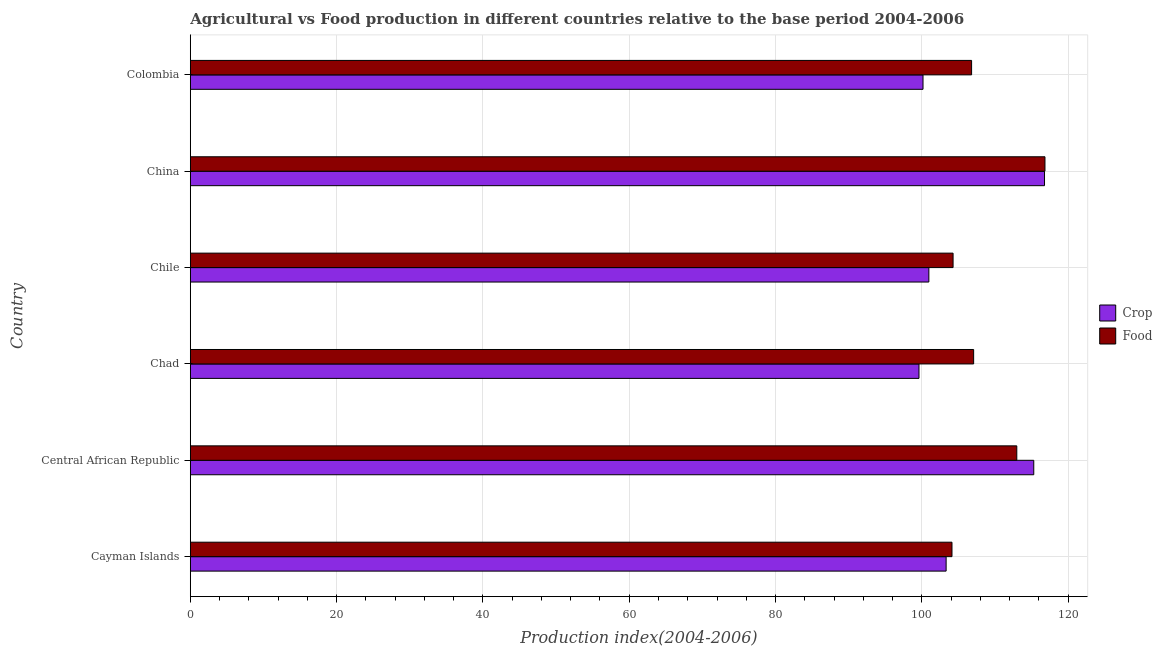How many different coloured bars are there?
Offer a very short reply. 2. How many groups of bars are there?
Keep it short and to the point. 6. Are the number of bars per tick equal to the number of legend labels?
Keep it short and to the point. Yes. Are the number of bars on each tick of the Y-axis equal?
Give a very brief answer. Yes. How many bars are there on the 6th tick from the top?
Your answer should be compact. 2. How many bars are there on the 6th tick from the bottom?
Offer a terse response. 2. What is the label of the 5th group of bars from the top?
Give a very brief answer. Central African Republic. What is the crop production index in Colombia?
Offer a terse response. 100.16. Across all countries, what is the maximum food production index?
Your answer should be compact. 116.83. Across all countries, what is the minimum crop production index?
Provide a short and direct response. 99.61. In which country was the food production index maximum?
Your answer should be very brief. China. In which country was the crop production index minimum?
Your answer should be compact. Chad. What is the total food production index in the graph?
Your answer should be very brief. 652.08. What is the difference between the food production index in Central African Republic and the crop production index in Chile?
Your answer should be compact. 12.02. What is the average food production index per country?
Ensure brevity in your answer.  108.68. What is the difference between the crop production index and food production index in Chad?
Give a very brief answer. -7.47. What is the ratio of the food production index in Chad to that in Chile?
Your answer should be compact. 1.03. Is the difference between the crop production index in Chad and Chile greater than the difference between the food production index in Chad and Chile?
Your response must be concise. No. What is the difference between the highest and the second highest crop production index?
Your answer should be very brief. 1.47. What is the difference between the highest and the lowest food production index?
Keep it short and to the point. 12.71. In how many countries, is the food production index greater than the average food production index taken over all countries?
Provide a succinct answer. 2. Is the sum of the food production index in Central African Republic and Chile greater than the maximum crop production index across all countries?
Offer a terse response. Yes. What does the 2nd bar from the top in Colombia represents?
Give a very brief answer. Crop. What does the 1st bar from the bottom in China represents?
Your answer should be compact. Crop. How many bars are there?
Provide a succinct answer. 12. How many countries are there in the graph?
Your response must be concise. 6. What is the difference between two consecutive major ticks on the X-axis?
Your answer should be compact. 20. Are the values on the major ticks of X-axis written in scientific E-notation?
Your answer should be compact. No. How many legend labels are there?
Offer a very short reply. 2. What is the title of the graph?
Provide a short and direct response. Agricultural vs Food production in different countries relative to the base period 2004-2006. What is the label or title of the X-axis?
Keep it short and to the point. Production index(2004-2006). What is the Production index(2004-2006) in Crop in Cayman Islands?
Your response must be concise. 103.32. What is the Production index(2004-2006) of Food in Cayman Islands?
Keep it short and to the point. 104.12. What is the Production index(2004-2006) in Crop in Central African Republic?
Your response must be concise. 115.3. What is the Production index(2004-2006) of Food in Central African Republic?
Keep it short and to the point. 112.98. What is the Production index(2004-2006) in Crop in Chad?
Your answer should be very brief. 99.61. What is the Production index(2004-2006) of Food in Chad?
Provide a short and direct response. 107.08. What is the Production index(2004-2006) of Crop in Chile?
Ensure brevity in your answer.  100.96. What is the Production index(2004-2006) in Food in Chile?
Your response must be concise. 104.27. What is the Production index(2004-2006) of Crop in China?
Your answer should be very brief. 116.77. What is the Production index(2004-2006) in Food in China?
Your response must be concise. 116.83. What is the Production index(2004-2006) of Crop in Colombia?
Give a very brief answer. 100.16. What is the Production index(2004-2006) in Food in Colombia?
Give a very brief answer. 106.8. Across all countries, what is the maximum Production index(2004-2006) of Crop?
Ensure brevity in your answer.  116.77. Across all countries, what is the maximum Production index(2004-2006) in Food?
Your answer should be very brief. 116.83. Across all countries, what is the minimum Production index(2004-2006) in Crop?
Give a very brief answer. 99.61. Across all countries, what is the minimum Production index(2004-2006) in Food?
Your response must be concise. 104.12. What is the total Production index(2004-2006) in Crop in the graph?
Your answer should be very brief. 636.12. What is the total Production index(2004-2006) of Food in the graph?
Offer a terse response. 652.08. What is the difference between the Production index(2004-2006) of Crop in Cayman Islands and that in Central African Republic?
Keep it short and to the point. -11.98. What is the difference between the Production index(2004-2006) of Food in Cayman Islands and that in Central African Republic?
Your answer should be very brief. -8.86. What is the difference between the Production index(2004-2006) in Crop in Cayman Islands and that in Chad?
Your response must be concise. 3.71. What is the difference between the Production index(2004-2006) in Food in Cayman Islands and that in Chad?
Offer a terse response. -2.96. What is the difference between the Production index(2004-2006) in Crop in Cayman Islands and that in Chile?
Keep it short and to the point. 2.36. What is the difference between the Production index(2004-2006) of Food in Cayman Islands and that in Chile?
Your answer should be very brief. -0.15. What is the difference between the Production index(2004-2006) in Crop in Cayman Islands and that in China?
Offer a very short reply. -13.45. What is the difference between the Production index(2004-2006) in Food in Cayman Islands and that in China?
Offer a very short reply. -12.71. What is the difference between the Production index(2004-2006) of Crop in Cayman Islands and that in Colombia?
Ensure brevity in your answer.  3.16. What is the difference between the Production index(2004-2006) in Food in Cayman Islands and that in Colombia?
Offer a very short reply. -2.68. What is the difference between the Production index(2004-2006) of Crop in Central African Republic and that in Chad?
Make the answer very short. 15.69. What is the difference between the Production index(2004-2006) of Crop in Central African Republic and that in Chile?
Your response must be concise. 14.34. What is the difference between the Production index(2004-2006) of Food in Central African Republic and that in Chile?
Give a very brief answer. 8.71. What is the difference between the Production index(2004-2006) in Crop in Central African Republic and that in China?
Your response must be concise. -1.47. What is the difference between the Production index(2004-2006) in Food in Central African Republic and that in China?
Keep it short and to the point. -3.85. What is the difference between the Production index(2004-2006) of Crop in Central African Republic and that in Colombia?
Give a very brief answer. 15.14. What is the difference between the Production index(2004-2006) of Food in Central African Republic and that in Colombia?
Offer a very short reply. 6.18. What is the difference between the Production index(2004-2006) of Crop in Chad and that in Chile?
Offer a terse response. -1.35. What is the difference between the Production index(2004-2006) of Food in Chad and that in Chile?
Your answer should be very brief. 2.81. What is the difference between the Production index(2004-2006) in Crop in Chad and that in China?
Offer a very short reply. -17.16. What is the difference between the Production index(2004-2006) of Food in Chad and that in China?
Your answer should be very brief. -9.75. What is the difference between the Production index(2004-2006) in Crop in Chad and that in Colombia?
Your answer should be very brief. -0.55. What is the difference between the Production index(2004-2006) of Food in Chad and that in Colombia?
Your response must be concise. 0.28. What is the difference between the Production index(2004-2006) in Crop in Chile and that in China?
Provide a succinct answer. -15.81. What is the difference between the Production index(2004-2006) in Food in Chile and that in China?
Ensure brevity in your answer.  -12.56. What is the difference between the Production index(2004-2006) of Crop in Chile and that in Colombia?
Make the answer very short. 0.8. What is the difference between the Production index(2004-2006) of Food in Chile and that in Colombia?
Ensure brevity in your answer.  -2.53. What is the difference between the Production index(2004-2006) of Crop in China and that in Colombia?
Your answer should be very brief. 16.61. What is the difference between the Production index(2004-2006) in Food in China and that in Colombia?
Offer a terse response. 10.03. What is the difference between the Production index(2004-2006) of Crop in Cayman Islands and the Production index(2004-2006) of Food in Central African Republic?
Make the answer very short. -9.66. What is the difference between the Production index(2004-2006) of Crop in Cayman Islands and the Production index(2004-2006) of Food in Chad?
Your answer should be compact. -3.76. What is the difference between the Production index(2004-2006) of Crop in Cayman Islands and the Production index(2004-2006) of Food in Chile?
Your response must be concise. -0.95. What is the difference between the Production index(2004-2006) in Crop in Cayman Islands and the Production index(2004-2006) in Food in China?
Offer a very short reply. -13.51. What is the difference between the Production index(2004-2006) of Crop in Cayman Islands and the Production index(2004-2006) of Food in Colombia?
Your answer should be compact. -3.48. What is the difference between the Production index(2004-2006) in Crop in Central African Republic and the Production index(2004-2006) in Food in Chad?
Give a very brief answer. 8.22. What is the difference between the Production index(2004-2006) in Crop in Central African Republic and the Production index(2004-2006) in Food in Chile?
Give a very brief answer. 11.03. What is the difference between the Production index(2004-2006) of Crop in Central African Republic and the Production index(2004-2006) of Food in China?
Your response must be concise. -1.53. What is the difference between the Production index(2004-2006) in Crop in Central African Republic and the Production index(2004-2006) in Food in Colombia?
Your response must be concise. 8.5. What is the difference between the Production index(2004-2006) in Crop in Chad and the Production index(2004-2006) in Food in Chile?
Keep it short and to the point. -4.66. What is the difference between the Production index(2004-2006) in Crop in Chad and the Production index(2004-2006) in Food in China?
Your response must be concise. -17.22. What is the difference between the Production index(2004-2006) of Crop in Chad and the Production index(2004-2006) of Food in Colombia?
Make the answer very short. -7.19. What is the difference between the Production index(2004-2006) of Crop in Chile and the Production index(2004-2006) of Food in China?
Make the answer very short. -15.87. What is the difference between the Production index(2004-2006) of Crop in Chile and the Production index(2004-2006) of Food in Colombia?
Provide a short and direct response. -5.84. What is the difference between the Production index(2004-2006) in Crop in China and the Production index(2004-2006) in Food in Colombia?
Keep it short and to the point. 9.97. What is the average Production index(2004-2006) in Crop per country?
Your answer should be very brief. 106.02. What is the average Production index(2004-2006) in Food per country?
Your response must be concise. 108.68. What is the difference between the Production index(2004-2006) of Crop and Production index(2004-2006) of Food in Central African Republic?
Make the answer very short. 2.32. What is the difference between the Production index(2004-2006) in Crop and Production index(2004-2006) in Food in Chad?
Make the answer very short. -7.47. What is the difference between the Production index(2004-2006) of Crop and Production index(2004-2006) of Food in Chile?
Provide a short and direct response. -3.31. What is the difference between the Production index(2004-2006) of Crop and Production index(2004-2006) of Food in China?
Make the answer very short. -0.06. What is the difference between the Production index(2004-2006) of Crop and Production index(2004-2006) of Food in Colombia?
Ensure brevity in your answer.  -6.64. What is the ratio of the Production index(2004-2006) of Crop in Cayman Islands to that in Central African Republic?
Give a very brief answer. 0.9. What is the ratio of the Production index(2004-2006) in Food in Cayman Islands to that in Central African Republic?
Ensure brevity in your answer.  0.92. What is the ratio of the Production index(2004-2006) of Crop in Cayman Islands to that in Chad?
Your response must be concise. 1.04. What is the ratio of the Production index(2004-2006) of Food in Cayman Islands to that in Chad?
Provide a succinct answer. 0.97. What is the ratio of the Production index(2004-2006) in Crop in Cayman Islands to that in Chile?
Offer a terse response. 1.02. What is the ratio of the Production index(2004-2006) of Crop in Cayman Islands to that in China?
Offer a terse response. 0.88. What is the ratio of the Production index(2004-2006) of Food in Cayman Islands to that in China?
Keep it short and to the point. 0.89. What is the ratio of the Production index(2004-2006) in Crop in Cayman Islands to that in Colombia?
Your answer should be compact. 1.03. What is the ratio of the Production index(2004-2006) of Food in Cayman Islands to that in Colombia?
Offer a very short reply. 0.97. What is the ratio of the Production index(2004-2006) in Crop in Central African Republic to that in Chad?
Make the answer very short. 1.16. What is the ratio of the Production index(2004-2006) in Food in Central African Republic to that in Chad?
Offer a very short reply. 1.06. What is the ratio of the Production index(2004-2006) of Crop in Central African Republic to that in Chile?
Your answer should be very brief. 1.14. What is the ratio of the Production index(2004-2006) in Food in Central African Republic to that in Chile?
Ensure brevity in your answer.  1.08. What is the ratio of the Production index(2004-2006) of Crop in Central African Republic to that in China?
Make the answer very short. 0.99. What is the ratio of the Production index(2004-2006) of Food in Central African Republic to that in China?
Make the answer very short. 0.97. What is the ratio of the Production index(2004-2006) in Crop in Central African Republic to that in Colombia?
Ensure brevity in your answer.  1.15. What is the ratio of the Production index(2004-2006) of Food in Central African Republic to that in Colombia?
Provide a succinct answer. 1.06. What is the ratio of the Production index(2004-2006) in Crop in Chad to that in Chile?
Offer a very short reply. 0.99. What is the ratio of the Production index(2004-2006) of Food in Chad to that in Chile?
Provide a short and direct response. 1.03. What is the ratio of the Production index(2004-2006) in Crop in Chad to that in China?
Your response must be concise. 0.85. What is the ratio of the Production index(2004-2006) in Food in Chad to that in China?
Your answer should be very brief. 0.92. What is the ratio of the Production index(2004-2006) in Crop in Chad to that in Colombia?
Provide a short and direct response. 0.99. What is the ratio of the Production index(2004-2006) in Crop in Chile to that in China?
Provide a short and direct response. 0.86. What is the ratio of the Production index(2004-2006) of Food in Chile to that in China?
Your answer should be compact. 0.89. What is the ratio of the Production index(2004-2006) in Food in Chile to that in Colombia?
Keep it short and to the point. 0.98. What is the ratio of the Production index(2004-2006) of Crop in China to that in Colombia?
Give a very brief answer. 1.17. What is the ratio of the Production index(2004-2006) of Food in China to that in Colombia?
Keep it short and to the point. 1.09. What is the difference between the highest and the second highest Production index(2004-2006) in Crop?
Give a very brief answer. 1.47. What is the difference between the highest and the second highest Production index(2004-2006) in Food?
Provide a short and direct response. 3.85. What is the difference between the highest and the lowest Production index(2004-2006) of Crop?
Provide a short and direct response. 17.16. What is the difference between the highest and the lowest Production index(2004-2006) of Food?
Offer a very short reply. 12.71. 